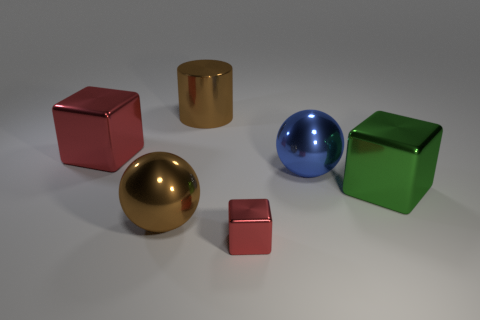Subtract all yellow balls. Subtract all cyan cubes. How many balls are left? 2 Add 2 large green blocks. How many objects exist? 8 Subtract all balls. How many objects are left? 4 Add 2 big green shiny objects. How many big green shiny objects are left? 3 Add 5 small red blocks. How many small red blocks exist? 6 Subtract 0 brown blocks. How many objects are left? 6 Subtract all brown cylinders. Subtract all big purple matte spheres. How many objects are left? 5 